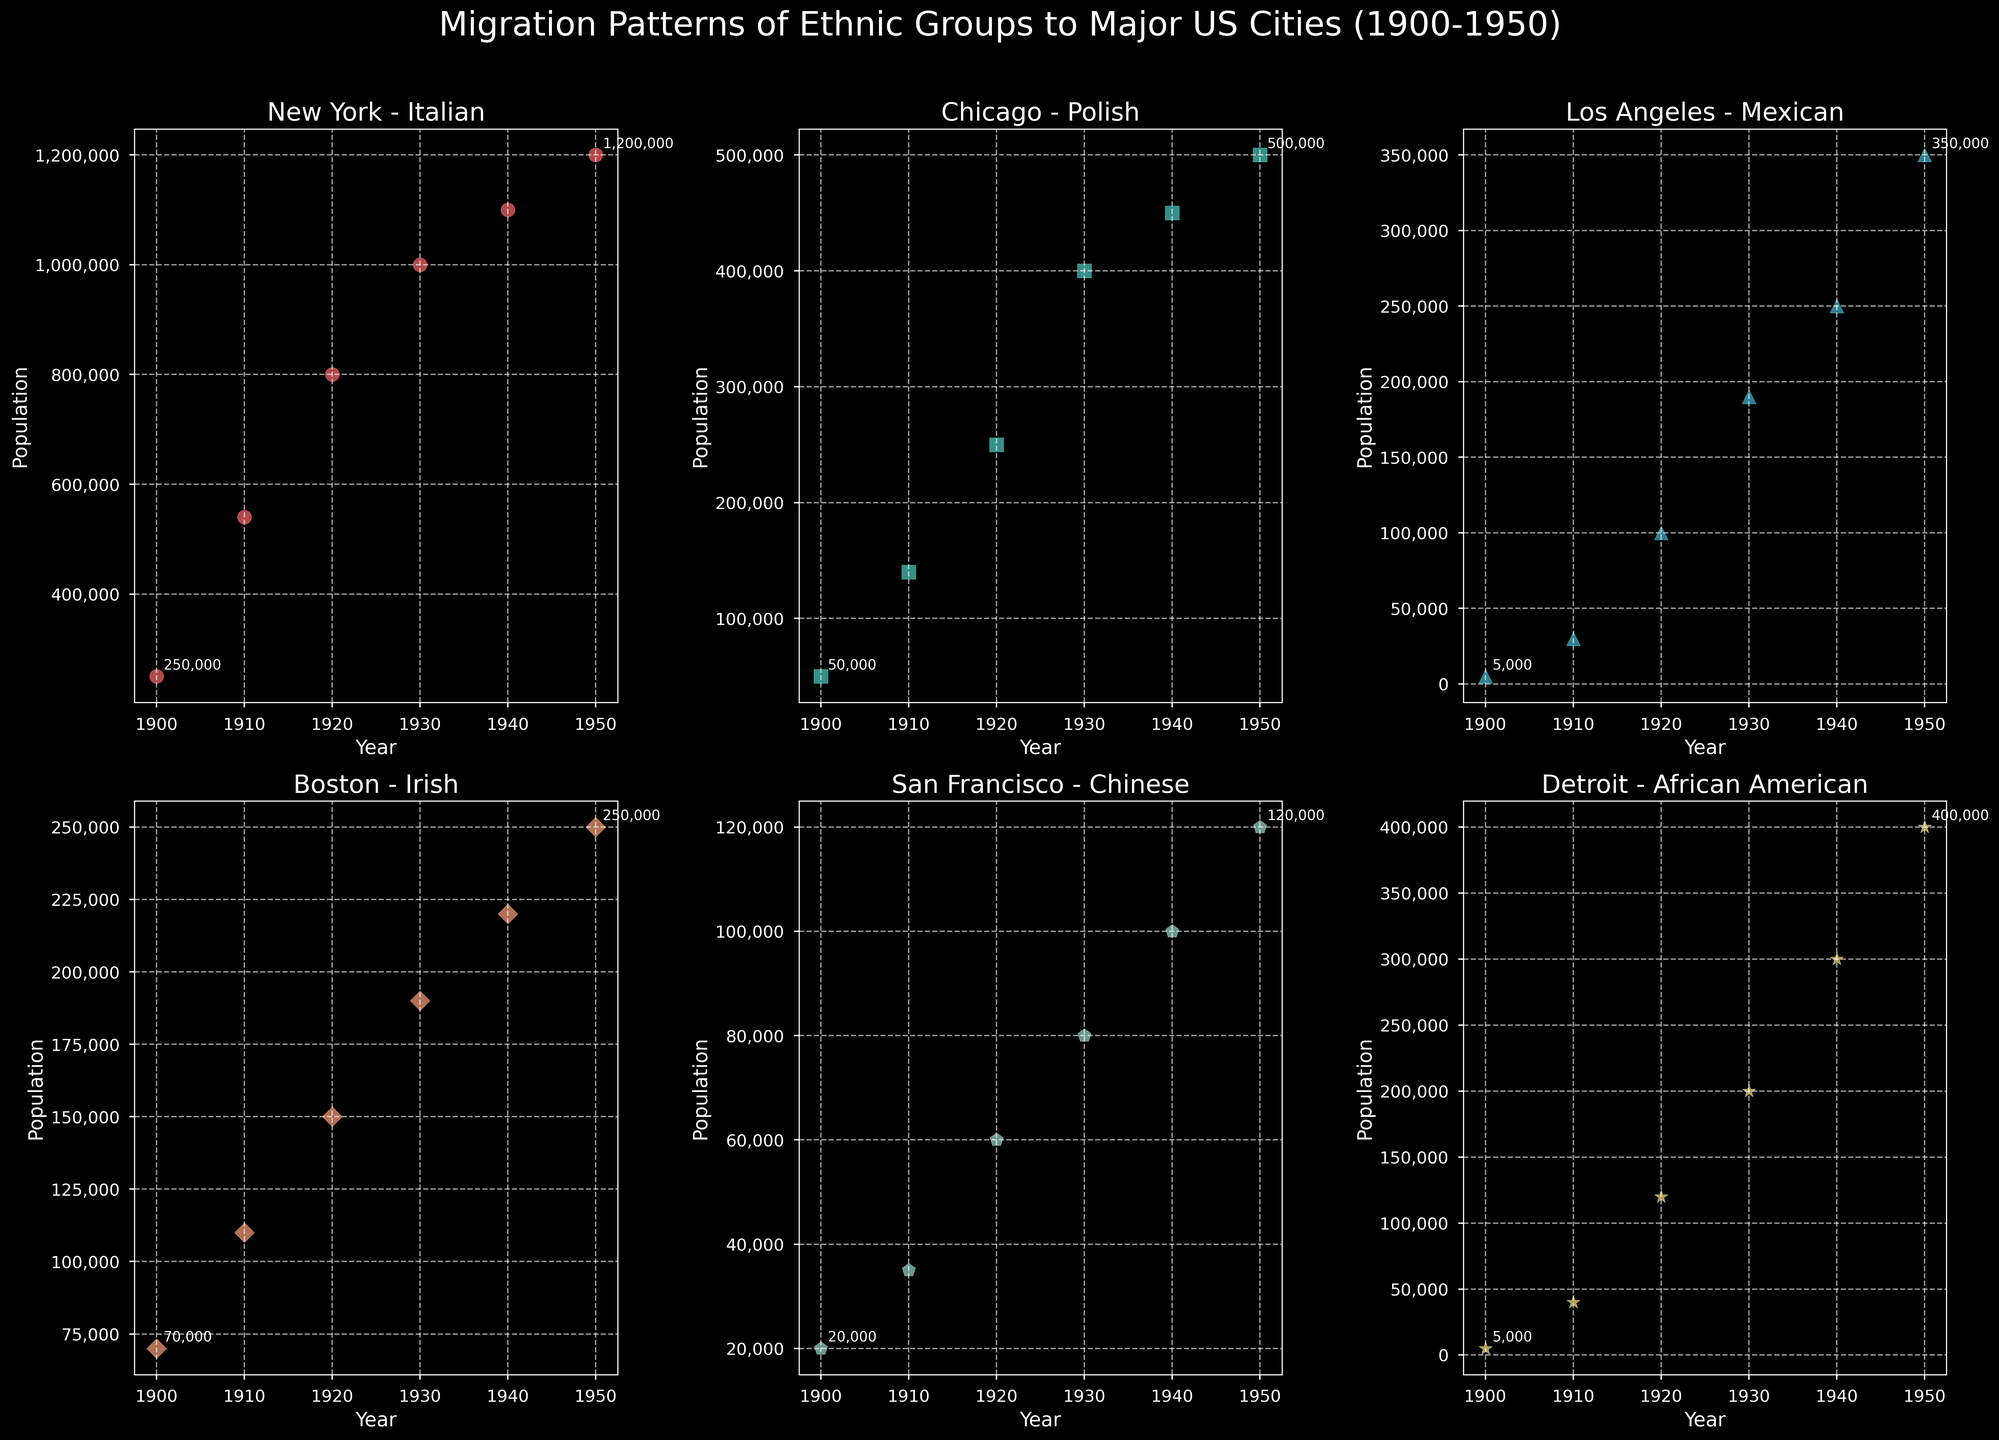Which ethnic group's population in New York increased the most from 1900 to 1950? To find the answer, note the initial and final populations of the Italian ethnic group in New York in 1900 and 1950: 250,000 and 1,200,000, respectively. The increase is 1,200,000 - 250,000 = 950,000. Comparing other groups: Polish in Chicago (450,000), Mexican in Los Angeles (345,000), Irish in Boston (180,000), Chinese in San Francisco (100,000), African American in Detroit (395,000). The Italian group in New York has the highest increase.
Answer: Italian Which city and ethnic group saw a population increase every decade from 1900 to 1950? Check each subplot for consistent increases across each decade from 1900 to 1950. Los Angeles (Mexican) goes from 5,000 to 350,000 consistently increasing every decade. New York (Italian), Chicago (Polish), Boston (Irish), San Francisco (Chinese), and Detroit (African American) also show consistent decade increases. This pattern appears for all cities and ethnic groups.
Answer: All Which ethnic group had the smallest population in the year 1900? Locate 1900 data points for all subplots: Italian in New York (250,000), Polish in Chicago (50,000), Mexican in Los Angeles (5,000), Irish in Boston (70,000), Chinese in San Francisco (20,000), African American in Detroit (5,000). Both Mexican in LA and African American in Detroit have the smallest initial populations.
Answer: Mexican (LA) & African American (Detroit) What was the population of Polish in Chicago in 1930? Check the population point in the Chicago subplot for the year 1930. The marker shows 400,000 Polish in Chicago at that year.
Answer: 400,000 Compare the population growth rates of the Mexican community in Los Angeles and the African American community in Detroit from 1900 to 1950. Which group grew faster? Calculate population growth: Mexican in LA (350,000 - 5,000 = 345,000), African American in Detroit (400,000 - 5,000 = 395,000). Next, calculate the growth rate percentage-wise: 
- Mexican growth rate = (345,000 / 5,000) * 100 = 6900%
- African American growth rate = (395,000 / 5,000) * 100 = 7900%
African American community in Detroit grew faster.
Answer: African American in Detroit Which subplot marker is green in color? The green marker color is associated with the subplot for the Chinese in San Francisco. Identify by looking at the figure and confirming visual details.
Answer: Chinese in San Francisco What's the combined population of the Irish in Boston and the Polish in Chicago in the year 1940? Locate 1940 data points: Irish in Boston (220,000), Polish in Chicago (450,000). Sum them: 220,000 + 450,000 = 670,000.
Answer: 670,000 Between 1920 and 1930, which city and ethnic group witnessed the highest population increase? Check 1920 and 1930 data points for all subplots:
- Italian in New York: 800,000 to 1,000,000 (200,000)
- Polish in Chicago: 250,000 to 400,000 (150,000)
- Mexican in Los Angeles: 100,000 to 190,000 (90,000)
- Irish in Boston: 150,000 to 190,000 (40,000)
- Chinese in SF: 60,000 to 80,000 (20,000)
- African American in Detroit 120,000 to 200,000 (80,000)
The Italian in New York had the highest increase of 200,000.
Answer: Italian in New York 